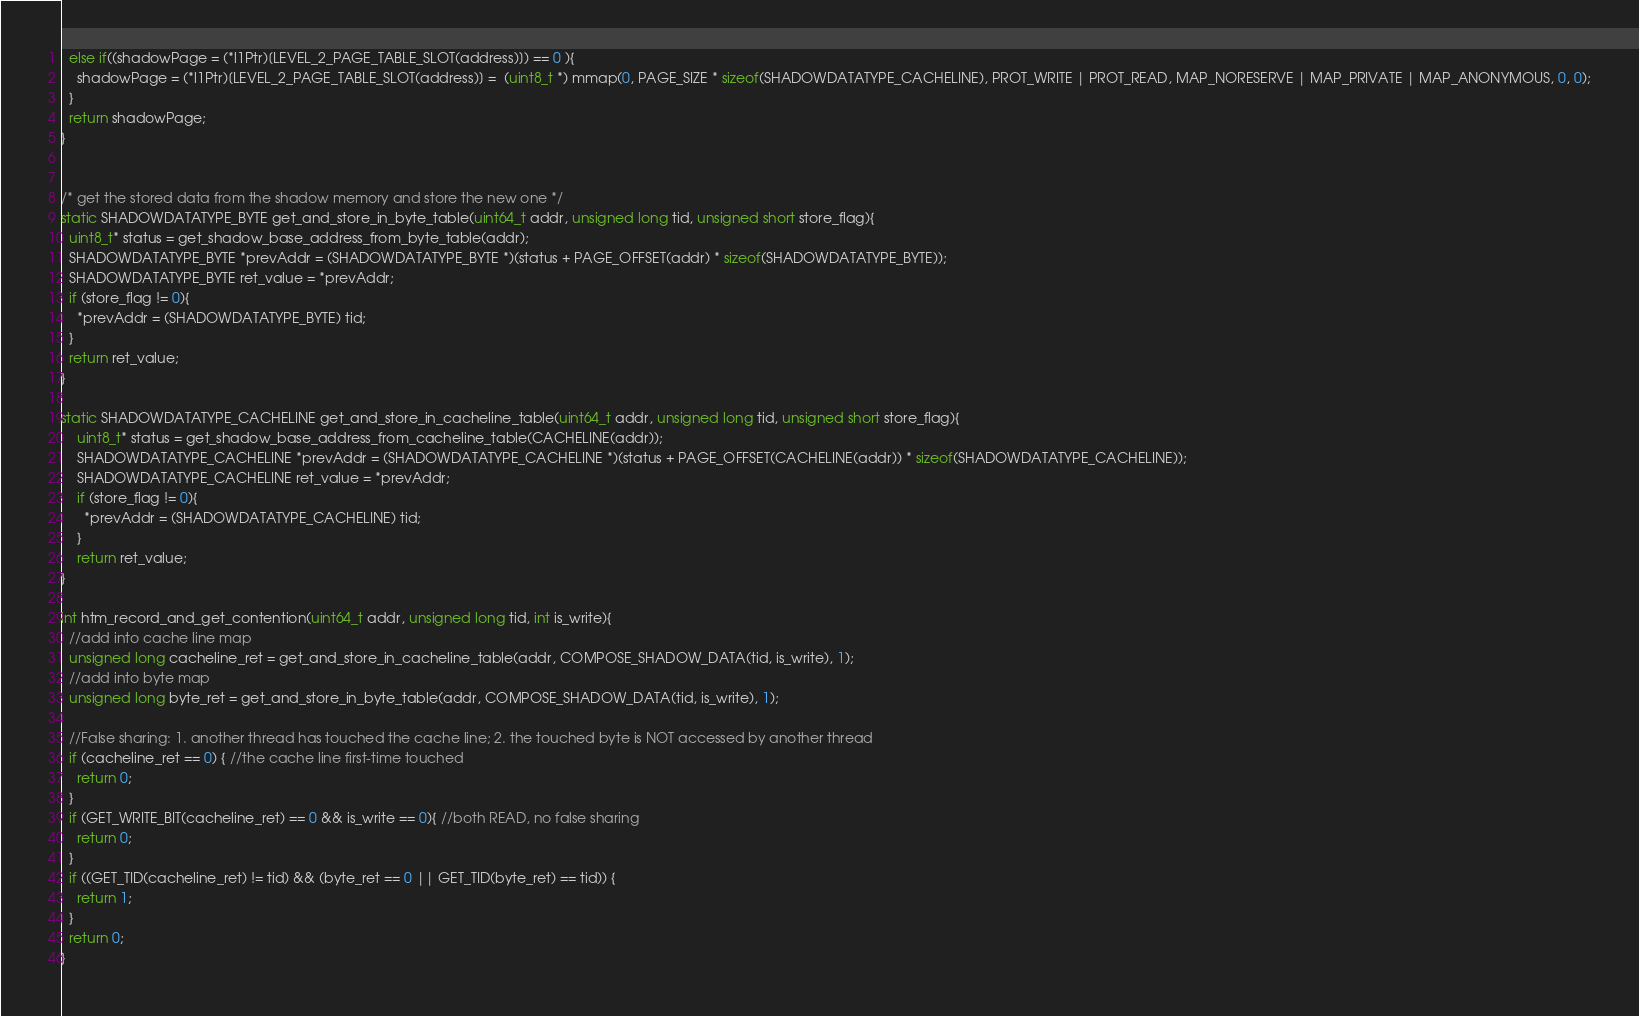Convert code to text. <code><loc_0><loc_0><loc_500><loc_500><_C_>  else if((shadowPage = (*l1Ptr)[LEVEL_2_PAGE_TABLE_SLOT(address)]) == 0 ){
    shadowPage = (*l1Ptr)[LEVEL_2_PAGE_TABLE_SLOT(address)] =  (uint8_t *) mmap(0, PAGE_SIZE * sizeof(SHADOWDATATYPE_CACHELINE), PROT_WRITE | PROT_READ, MAP_NORESERVE | MAP_PRIVATE | MAP_ANONYMOUS, 0, 0);
  }
  return shadowPage;
}


/* get the stored data from the shadow memory and store the new one */
static SHADOWDATATYPE_BYTE get_and_store_in_byte_table(uint64_t addr, unsigned long tid, unsigned short store_flag){
  uint8_t* status = get_shadow_base_address_from_byte_table(addr);
  SHADOWDATATYPE_BYTE *prevAddr = (SHADOWDATATYPE_BYTE *)(status + PAGE_OFFSET(addr) * sizeof(SHADOWDATATYPE_BYTE));
  SHADOWDATATYPE_BYTE ret_value = *prevAddr;
  if (store_flag != 0){
    *prevAddr = (SHADOWDATATYPE_BYTE) tid;
  }
  return ret_value;
}

static SHADOWDATATYPE_CACHELINE get_and_store_in_cacheline_table(uint64_t addr, unsigned long tid, unsigned short store_flag){
    uint8_t* status = get_shadow_base_address_from_cacheline_table(CACHELINE(addr));
    SHADOWDATATYPE_CACHELINE *prevAddr = (SHADOWDATATYPE_CACHELINE *)(status + PAGE_OFFSET(CACHELINE(addr)) * sizeof(SHADOWDATATYPE_CACHELINE));
    SHADOWDATATYPE_CACHELINE ret_value = *prevAddr;
    if (store_flag != 0){
      *prevAddr = (SHADOWDATATYPE_CACHELINE) tid;
    }
    return ret_value;
}

int htm_record_and_get_contention(uint64_t addr, unsigned long tid, int is_write){
  //add into cache line map
  unsigned long cacheline_ret = get_and_store_in_cacheline_table(addr, COMPOSE_SHADOW_DATA(tid, is_write), 1);
  //add into byte map
  unsigned long byte_ret = get_and_store_in_byte_table(addr, COMPOSE_SHADOW_DATA(tid, is_write), 1);

  //False sharing: 1. another thread has touched the cache line; 2. the touched byte is NOT accessed by another thread
  if (cacheline_ret == 0) { //the cache line first-time touched
    return 0;
  }
  if (GET_WRITE_BIT(cacheline_ret) == 0 && is_write == 0){ //both READ, no false sharing
    return 0;
  }
  if ((GET_TID(cacheline_ret) != tid) && (byte_ret == 0 || GET_TID(byte_ret) == tid)) {
    return 1;
  }
  return 0;
}

</code> 